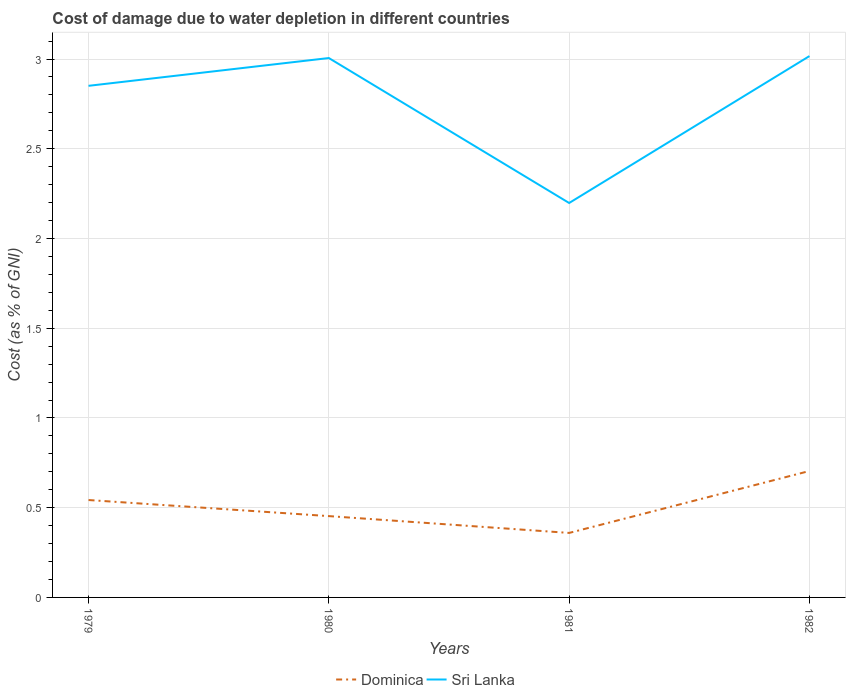How many different coloured lines are there?
Your answer should be very brief. 2. Is the number of lines equal to the number of legend labels?
Your answer should be very brief. Yes. Across all years, what is the maximum cost of damage caused due to water depletion in Dominica?
Provide a succinct answer. 0.36. In which year was the cost of damage caused due to water depletion in Sri Lanka maximum?
Ensure brevity in your answer.  1981. What is the total cost of damage caused due to water depletion in Sri Lanka in the graph?
Give a very brief answer. -0.17. What is the difference between the highest and the second highest cost of damage caused due to water depletion in Dominica?
Give a very brief answer. 0.35. Is the cost of damage caused due to water depletion in Sri Lanka strictly greater than the cost of damage caused due to water depletion in Dominica over the years?
Make the answer very short. No. How many lines are there?
Your answer should be very brief. 2. How many years are there in the graph?
Your answer should be very brief. 4. Does the graph contain grids?
Your response must be concise. Yes. How are the legend labels stacked?
Ensure brevity in your answer.  Horizontal. What is the title of the graph?
Offer a terse response. Cost of damage due to water depletion in different countries. What is the label or title of the X-axis?
Your response must be concise. Years. What is the label or title of the Y-axis?
Make the answer very short. Cost (as % of GNI). What is the Cost (as % of GNI) in Dominica in 1979?
Make the answer very short. 0.54. What is the Cost (as % of GNI) in Sri Lanka in 1979?
Your response must be concise. 2.85. What is the Cost (as % of GNI) of Dominica in 1980?
Ensure brevity in your answer.  0.45. What is the Cost (as % of GNI) in Sri Lanka in 1980?
Give a very brief answer. 3.01. What is the Cost (as % of GNI) of Dominica in 1981?
Your response must be concise. 0.36. What is the Cost (as % of GNI) of Sri Lanka in 1981?
Give a very brief answer. 2.2. What is the Cost (as % of GNI) in Dominica in 1982?
Your response must be concise. 0.7. What is the Cost (as % of GNI) of Sri Lanka in 1982?
Make the answer very short. 3.02. Across all years, what is the maximum Cost (as % of GNI) of Dominica?
Provide a succinct answer. 0.7. Across all years, what is the maximum Cost (as % of GNI) of Sri Lanka?
Your answer should be compact. 3.02. Across all years, what is the minimum Cost (as % of GNI) in Dominica?
Provide a short and direct response. 0.36. Across all years, what is the minimum Cost (as % of GNI) in Sri Lanka?
Give a very brief answer. 2.2. What is the total Cost (as % of GNI) of Dominica in the graph?
Provide a succinct answer. 2.06. What is the total Cost (as % of GNI) of Sri Lanka in the graph?
Provide a succinct answer. 11.07. What is the difference between the Cost (as % of GNI) in Dominica in 1979 and that in 1980?
Your answer should be compact. 0.09. What is the difference between the Cost (as % of GNI) in Sri Lanka in 1979 and that in 1980?
Keep it short and to the point. -0.15. What is the difference between the Cost (as % of GNI) in Dominica in 1979 and that in 1981?
Offer a very short reply. 0.18. What is the difference between the Cost (as % of GNI) in Sri Lanka in 1979 and that in 1981?
Provide a short and direct response. 0.65. What is the difference between the Cost (as % of GNI) of Dominica in 1979 and that in 1982?
Make the answer very short. -0.16. What is the difference between the Cost (as % of GNI) of Sri Lanka in 1979 and that in 1982?
Ensure brevity in your answer.  -0.17. What is the difference between the Cost (as % of GNI) of Dominica in 1980 and that in 1981?
Your answer should be compact. 0.09. What is the difference between the Cost (as % of GNI) of Sri Lanka in 1980 and that in 1981?
Give a very brief answer. 0.81. What is the difference between the Cost (as % of GNI) in Dominica in 1980 and that in 1982?
Ensure brevity in your answer.  -0.25. What is the difference between the Cost (as % of GNI) of Sri Lanka in 1980 and that in 1982?
Your answer should be very brief. -0.01. What is the difference between the Cost (as % of GNI) of Dominica in 1981 and that in 1982?
Your answer should be compact. -0.35. What is the difference between the Cost (as % of GNI) in Sri Lanka in 1981 and that in 1982?
Your answer should be very brief. -0.82. What is the difference between the Cost (as % of GNI) of Dominica in 1979 and the Cost (as % of GNI) of Sri Lanka in 1980?
Provide a short and direct response. -2.46. What is the difference between the Cost (as % of GNI) in Dominica in 1979 and the Cost (as % of GNI) in Sri Lanka in 1981?
Provide a short and direct response. -1.66. What is the difference between the Cost (as % of GNI) of Dominica in 1979 and the Cost (as % of GNI) of Sri Lanka in 1982?
Give a very brief answer. -2.47. What is the difference between the Cost (as % of GNI) of Dominica in 1980 and the Cost (as % of GNI) of Sri Lanka in 1981?
Give a very brief answer. -1.74. What is the difference between the Cost (as % of GNI) in Dominica in 1980 and the Cost (as % of GNI) in Sri Lanka in 1982?
Provide a succinct answer. -2.56. What is the difference between the Cost (as % of GNI) in Dominica in 1981 and the Cost (as % of GNI) in Sri Lanka in 1982?
Offer a very short reply. -2.66. What is the average Cost (as % of GNI) of Dominica per year?
Make the answer very short. 0.51. What is the average Cost (as % of GNI) in Sri Lanka per year?
Your answer should be very brief. 2.77. In the year 1979, what is the difference between the Cost (as % of GNI) in Dominica and Cost (as % of GNI) in Sri Lanka?
Make the answer very short. -2.31. In the year 1980, what is the difference between the Cost (as % of GNI) of Dominica and Cost (as % of GNI) of Sri Lanka?
Offer a very short reply. -2.55. In the year 1981, what is the difference between the Cost (as % of GNI) in Dominica and Cost (as % of GNI) in Sri Lanka?
Offer a terse response. -1.84. In the year 1982, what is the difference between the Cost (as % of GNI) in Dominica and Cost (as % of GNI) in Sri Lanka?
Your answer should be compact. -2.31. What is the ratio of the Cost (as % of GNI) in Dominica in 1979 to that in 1980?
Offer a very short reply. 1.2. What is the ratio of the Cost (as % of GNI) in Sri Lanka in 1979 to that in 1980?
Provide a succinct answer. 0.95. What is the ratio of the Cost (as % of GNI) of Dominica in 1979 to that in 1981?
Make the answer very short. 1.51. What is the ratio of the Cost (as % of GNI) in Sri Lanka in 1979 to that in 1981?
Give a very brief answer. 1.3. What is the ratio of the Cost (as % of GNI) of Dominica in 1979 to that in 1982?
Your response must be concise. 0.77. What is the ratio of the Cost (as % of GNI) in Sri Lanka in 1979 to that in 1982?
Make the answer very short. 0.95. What is the ratio of the Cost (as % of GNI) in Dominica in 1980 to that in 1981?
Your response must be concise. 1.26. What is the ratio of the Cost (as % of GNI) of Sri Lanka in 1980 to that in 1981?
Offer a very short reply. 1.37. What is the ratio of the Cost (as % of GNI) in Dominica in 1980 to that in 1982?
Give a very brief answer. 0.64. What is the ratio of the Cost (as % of GNI) in Sri Lanka in 1980 to that in 1982?
Your response must be concise. 1. What is the ratio of the Cost (as % of GNI) of Dominica in 1981 to that in 1982?
Provide a short and direct response. 0.51. What is the ratio of the Cost (as % of GNI) in Sri Lanka in 1981 to that in 1982?
Ensure brevity in your answer.  0.73. What is the difference between the highest and the second highest Cost (as % of GNI) in Dominica?
Give a very brief answer. 0.16. What is the difference between the highest and the second highest Cost (as % of GNI) in Sri Lanka?
Keep it short and to the point. 0.01. What is the difference between the highest and the lowest Cost (as % of GNI) in Dominica?
Make the answer very short. 0.35. What is the difference between the highest and the lowest Cost (as % of GNI) of Sri Lanka?
Offer a very short reply. 0.82. 